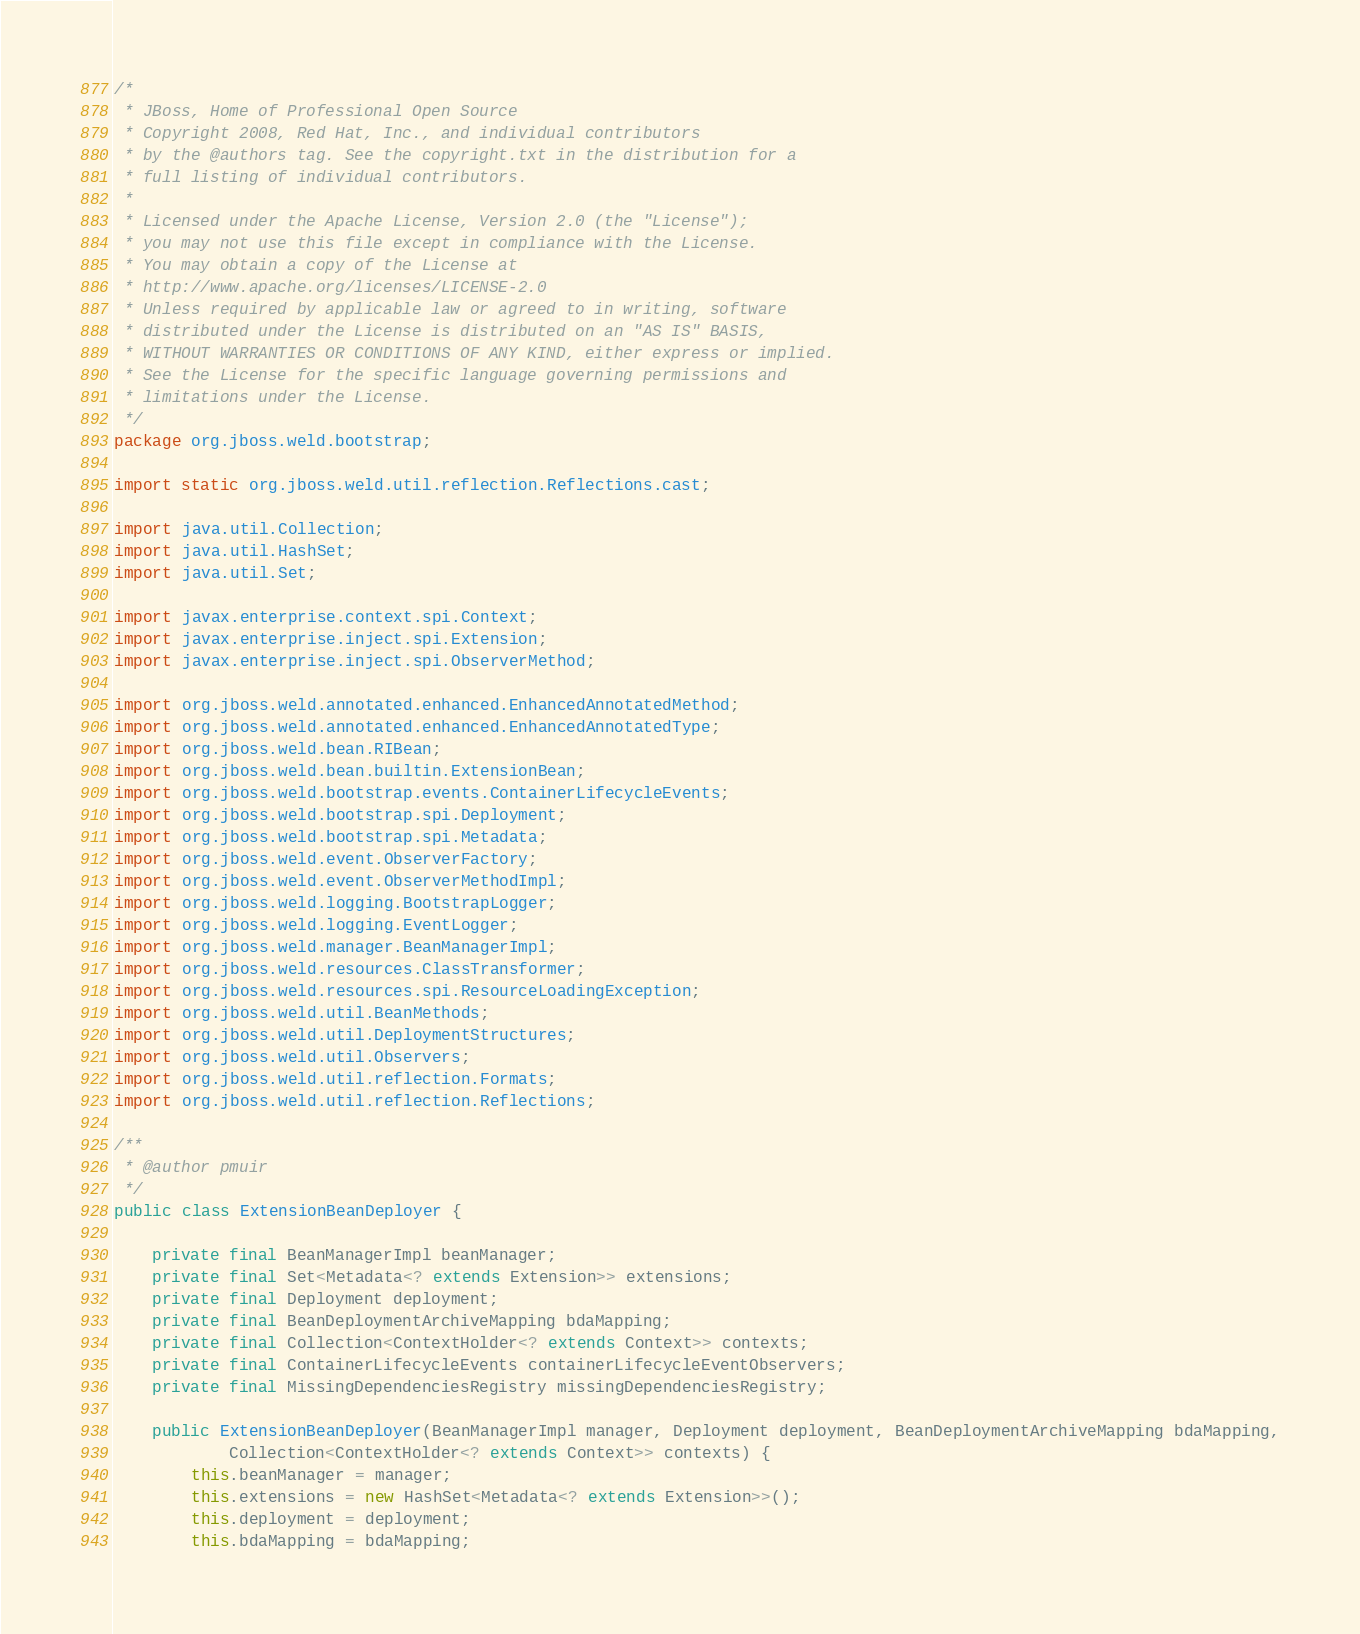<code> <loc_0><loc_0><loc_500><loc_500><_Java_>/*
 * JBoss, Home of Professional Open Source
 * Copyright 2008, Red Hat, Inc., and individual contributors
 * by the @authors tag. See the copyright.txt in the distribution for a
 * full listing of individual contributors.
 *
 * Licensed under the Apache License, Version 2.0 (the "License");
 * you may not use this file except in compliance with the License.
 * You may obtain a copy of the License at
 * http://www.apache.org/licenses/LICENSE-2.0
 * Unless required by applicable law or agreed to in writing, software
 * distributed under the License is distributed on an "AS IS" BASIS,
 * WITHOUT WARRANTIES OR CONDITIONS OF ANY KIND, either express or implied.
 * See the License for the specific language governing permissions and
 * limitations under the License.
 */
package org.jboss.weld.bootstrap;

import static org.jboss.weld.util.reflection.Reflections.cast;

import java.util.Collection;
import java.util.HashSet;
import java.util.Set;

import javax.enterprise.context.spi.Context;
import javax.enterprise.inject.spi.Extension;
import javax.enterprise.inject.spi.ObserverMethod;

import org.jboss.weld.annotated.enhanced.EnhancedAnnotatedMethod;
import org.jboss.weld.annotated.enhanced.EnhancedAnnotatedType;
import org.jboss.weld.bean.RIBean;
import org.jboss.weld.bean.builtin.ExtensionBean;
import org.jboss.weld.bootstrap.events.ContainerLifecycleEvents;
import org.jboss.weld.bootstrap.spi.Deployment;
import org.jboss.weld.bootstrap.spi.Metadata;
import org.jboss.weld.event.ObserverFactory;
import org.jboss.weld.event.ObserverMethodImpl;
import org.jboss.weld.logging.BootstrapLogger;
import org.jboss.weld.logging.EventLogger;
import org.jboss.weld.manager.BeanManagerImpl;
import org.jboss.weld.resources.ClassTransformer;
import org.jboss.weld.resources.spi.ResourceLoadingException;
import org.jboss.weld.util.BeanMethods;
import org.jboss.weld.util.DeploymentStructures;
import org.jboss.weld.util.Observers;
import org.jboss.weld.util.reflection.Formats;
import org.jboss.weld.util.reflection.Reflections;

/**
 * @author pmuir
 */
public class ExtensionBeanDeployer {

    private final BeanManagerImpl beanManager;
    private final Set<Metadata<? extends Extension>> extensions;
    private final Deployment deployment;
    private final BeanDeploymentArchiveMapping bdaMapping;
    private final Collection<ContextHolder<? extends Context>> contexts;
    private final ContainerLifecycleEvents containerLifecycleEventObservers;
    private final MissingDependenciesRegistry missingDependenciesRegistry;

    public ExtensionBeanDeployer(BeanManagerImpl manager, Deployment deployment, BeanDeploymentArchiveMapping bdaMapping,
            Collection<ContextHolder<? extends Context>> contexts) {
        this.beanManager = manager;
        this.extensions = new HashSet<Metadata<? extends Extension>>();
        this.deployment = deployment;
        this.bdaMapping = bdaMapping;</code> 